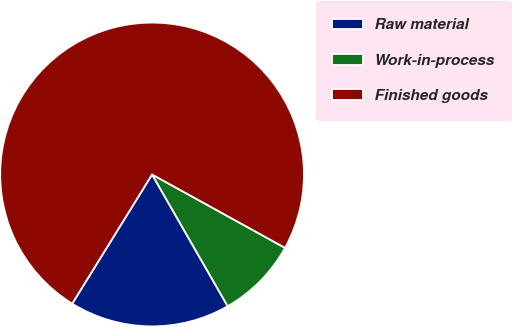Convert chart to OTSL. <chart><loc_0><loc_0><loc_500><loc_500><pie_chart><fcel>Raw material<fcel>Work-in-process<fcel>Finished goods<nl><fcel>17.11%<fcel>8.68%<fcel>74.21%<nl></chart> 